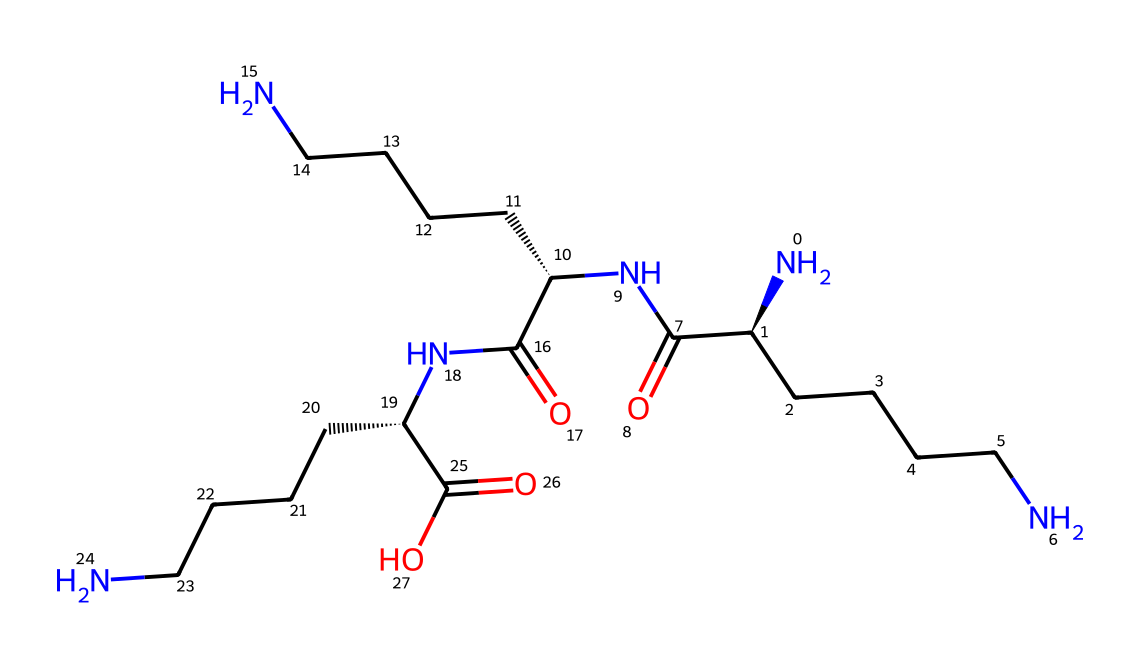What is the primary functional group present in this polymer? The chemical structure includes an amide (-C(=O)N-) functional group, which is characteristic of polylysine polymers.
Answer: amide How many nitrogen atoms are present in the structure? Counting the nitrogen atoms from the SMILES representation shows there are three nitrogen atoms involved in the amide groups of the polymer.
Answer: three What is the length of the carbon chain in this polylysine derivative? The SMILES notation indicates that there are four carbon atoms in a linear chain attached to each nitrogen atom, giving a total of 12 carbon atoms.
Answer: 12 What type of polymer is polylysine classified as? Given the repeating units of amino acids in its structure, polylysine is classified as a polypeptide or a protein polymer.
Answer: polypeptide What type of interactions could this polymer have with microbial membranes? The positively charged amino groups in polylysine can interact strongly with negatively charged microbial membranes, leading to disruption and antimicrobial activity.
Answer: electrostatic interactions What is the significance of the terminal carboxylic acid in this polymer? The terminal carboxylic acid (-COOH) group enhances solubility in biological environments and may contribute to the antimicrobial properties by modifying the polymer's surface charge.
Answer: solubility and antimicrobial properties How does the polymer structure impact its application in medical coatings? The polymer's structure, which includes hydrophilic and charged regions, allows it to form strong interactions with substrates and enhance biocompatibility and antimicrobial effects in medical coatings.
Answer: strong interactions and biocompatibility 